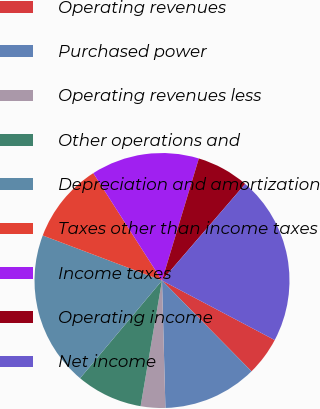Convert chart to OTSL. <chart><loc_0><loc_0><loc_500><loc_500><pie_chart><fcel>Operating revenues<fcel>Purchased power<fcel>Operating revenues less<fcel>Other operations and<fcel>Depreciation and amortization<fcel>Taxes other than income taxes<fcel>Income taxes<fcel>Operating income<fcel>Net income<nl><fcel>4.88%<fcel>11.96%<fcel>3.11%<fcel>8.42%<fcel>19.65%<fcel>10.19%<fcel>13.73%<fcel>6.65%<fcel>21.42%<nl></chart> 